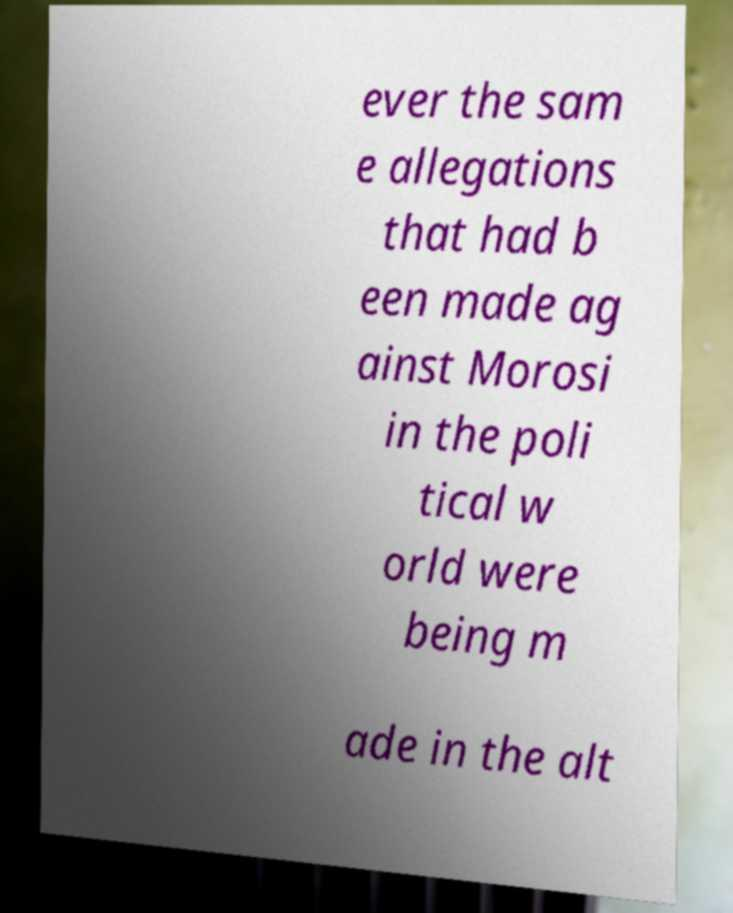Could you assist in decoding the text presented in this image and type it out clearly? ever the sam e allegations that had b een made ag ainst Morosi in the poli tical w orld were being m ade in the alt 